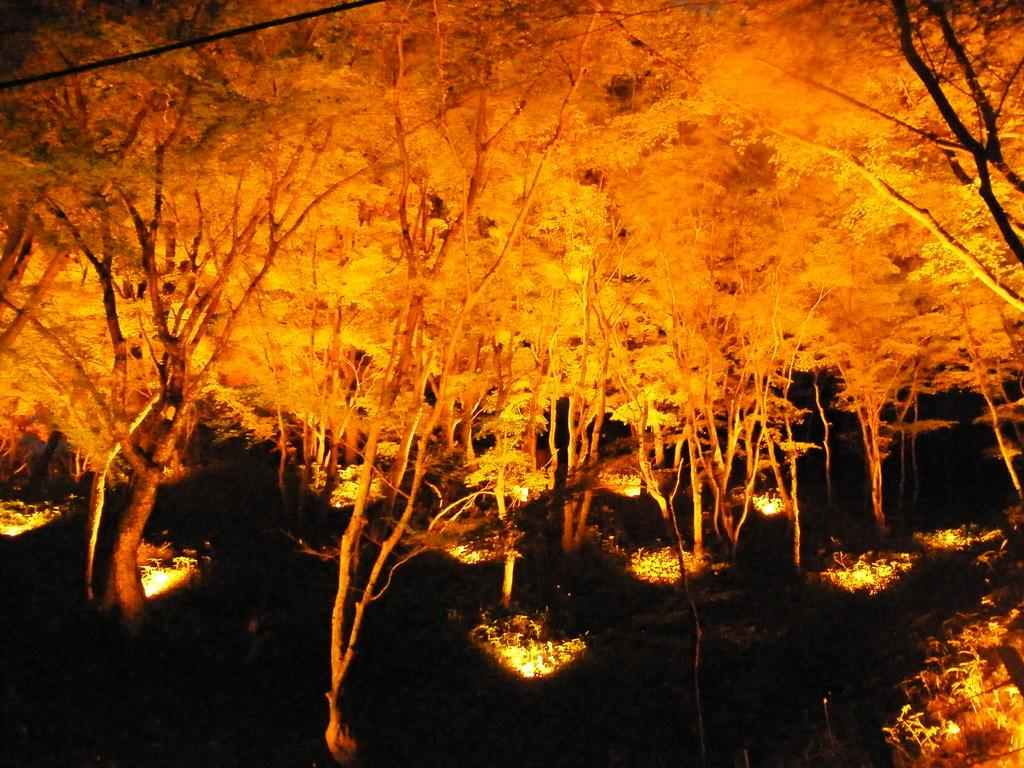What type of natural elements can be seen in the image? There are trees in the image. What artificial elements can be seen in the image? There are lights in the image. What language is being spoken by the trees in the image? Trees do not speak any language, so this question cannot be answered. 